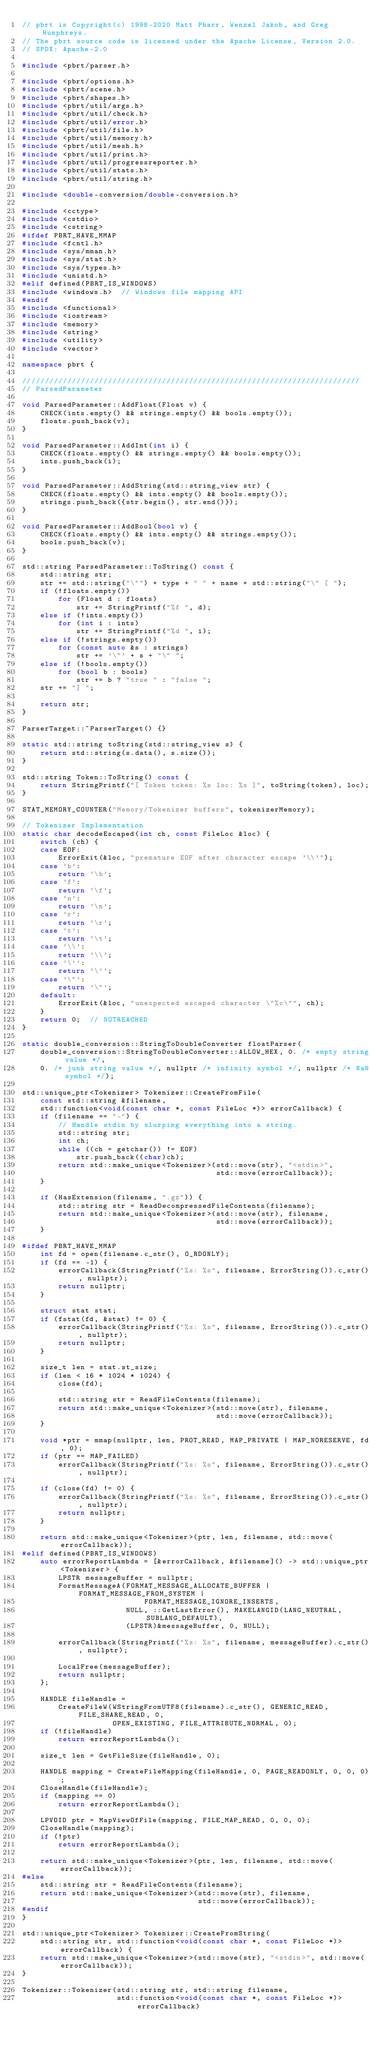Convert code to text. <code><loc_0><loc_0><loc_500><loc_500><_C++_>// pbrt is Copyright(c) 1998-2020 Matt Pharr, Wenzel Jakob, and Greg Humphreys.
// The pbrt source code is licensed under the Apache License, Version 2.0.
// SPDX: Apache-2.0

#include <pbrt/parser.h>

#include <pbrt/options.h>
#include <pbrt/scene.h>
#include <pbrt/shapes.h>
#include <pbrt/util/args.h>
#include <pbrt/util/check.h>
#include <pbrt/util/error.h>
#include <pbrt/util/file.h>
#include <pbrt/util/memory.h>
#include <pbrt/util/mesh.h>
#include <pbrt/util/print.h>
#include <pbrt/util/progressreporter.h>
#include <pbrt/util/stats.h>
#include <pbrt/util/string.h>

#include <double-conversion/double-conversion.h>

#include <cctype>
#include <cstdio>
#include <cstring>
#ifdef PBRT_HAVE_MMAP
#include <fcntl.h>
#include <sys/mman.h>
#include <sys/stat.h>
#include <sys/types.h>
#include <unistd.h>
#elif defined(PBRT_IS_WINDOWS)
#include <windows.h>  // Windows file mapping API
#endif
#include <functional>
#include <iostream>
#include <memory>
#include <string>
#include <utility>
#include <vector>

namespace pbrt {

///////////////////////////////////////////////////////////////////////////
// ParsedParameter

void ParsedParameter::AddFloat(Float v) {
    CHECK(ints.empty() && strings.empty() && bools.empty());
    floats.push_back(v);
}

void ParsedParameter::AddInt(int i) {
    CHECK(floats.empty() && strings.empty() && bools.empty());
    ints.push_back(i);
}

void ParsedParameter::AddString(std::string_view str) {
    CHECK(floats.empty() && ints.empty() && bools.empty());
    strings.push_back({str.begin(), str.end()});
}

void ParsedParameter::AddBool(bool v) {
    CHECK(floats.empty() && ints.empty() && strings.empty());
    bools.push_back(v);
}

std::string ParsedParameter::ToString() const {
    std::string str;
    str += std::string("\"") + type + " " + name + std::string("\" [ ");
    if (!floats.empty())
        for (Float d : floats)
            str += StringPrintf("%f ", d);
    else if (!ints.empty())
        for (int i : ints)
            str += StringPrintf("%d ", i);
    else if (!strings.empty())
        for (const auto &s : strings)
            str += '\"' + s + "\" ";
    else if (!bools.empty())
        for (bool b : bools)
            str += b ? "true " : "false ";
    str += "] ";

    return str;
}

ParserTarget::~ParserTarget() {}

static std::string toString(std::string_view s) {
    return std::string(s.data(), s.size());
}

std::string Token::ToString() const {
    return StringPrintf("[ Token token: %s loc: %s ]", toString(token), loc);
}

STAT_MEMORY_COUNTER("Memory/Tokenizer buffers", tokenizerMemory);

// Tokenizer Implementation
static char decodeEscaped(int ch, const FileLoc &loc) {
    switch (ch) {
    case EOF:
        ErrorExit(&loc, "premature EOF after character escape '\\'");
    case 'b':
        return '\b';
    case 'f':
        return '\f';
    case 'n':
        return '\n';
    case 'r':
        return '\r';
    case 't':
        return '\t';
    case '\\':
        return '\\';
    case '\'':
        return '\'';
    case '\"':
        return '\"';
    default:
        ErrorExit(&loc, "unexpected escaped character \"%c\"", ch);
    }
    return 0;  // NOTREACHED
}

static double_conversion::StringToDoubleConverter floatParser(
    double_conversion::StringToDoubleConverter::ALLOW_HEX, 0. /* empty string value */,
    0. /* junk string value */, nullptr /* infinity symbol */, nullptr /* NaN symbol */);

std::unique_ptr<Tokenizer> Tokenizer::CreateFromFile(
    const std::string &filename,
    std::function<void(const char *, const FileLoc *)> errorCallback) {
    if (filename == "-") {
        // Handle stdin by slurping everything into a string.
        std::string str;
        int ch;
        while ((ch = getchar()) != EOF)
            str.push_back((char)ch);
        return std::make_unique<Tokenizer>(std::move(str), "<stdin>",
                                           std::move(errorCallback));
    }

    if (HasExtension(filename, ".gz")) {
        std::string str = ReadDecompressedFileContents(filename);
        return std::make_unique<Tokenizer>(std::move(str), filename,
                                           std::move(errorCallback));
    }

#ifdef PBRT_HAVE_MMAP
    int fd = open(filename.c_str(), O_RDONLY);
    if (fd == -1) {
        errorCallback(StringPrintf("%s: %s", filename, ErrorString()).c_str(), nullptr);
        return nullptr;
    }

    struct stat stat;
    if (fstat(fd, &stat) != 0) {
        errorCallback(StringPrintf("%s: %s", filename, ErrorString()).c_str(), nullptr);
        return nullptr;
    }

    size_t len = stat.st_size;
    if (len < 16 * 1024 * 1024) {
        close(fd);

        std::string str = ReadFileContents(filename);
        return std::make_unique<Tokenizer>(std::move(str), filename,
                                           std::move(errorCallback));
    }

    void *ptr = mmap(nullptr, len, PROT_READ, MAP_PRIVATE | MAP_NORESERVE, fd, 0);
    if (ptr == MAP_FAILED)
        errorCallback(StringPrintf("%s: %s", filename, ErrorString()).c_str(), nullptr);

    if (close(fd) != 0) {
        errorCallback(StringPrintf("%s: %s", filename, ErrorString()).c_str(), nullptr);
        return nullptr;
    }

    return std::make_unique<Tokenizer>(ptr, len, filename, std::move(errorCallback));
#elif defined(PBRT_IS_WINDOWS)
    auto errorReportLambda = [&errorCallback, &filename]() -> std::unique_ptr<Tokenizer> {
        LPSTR messageBuffer = nullptr;
        FormatMessageA(FORMAT_MESSAGE_ALLOCATE_BUFFER | FORMAT_MESSAGE_FROM_SYSTEM |
                           FORMAT_MESSAGE_IGNORE_INSERTS,
                       NULL, ::GetLastError(), MAKELANGID(LANG_NEUTRAL, SUBLANG_DEFAULT),
                       (LPSTR)&messageBuffer, 0, NULL);

        errorCallback(StringPrintf("%s: %s", filename, messageBuffer).c_str(), nullptr);

        LocalFree(messageBuffer);
        return nullptr;
    };

    HANDLE fileHandle =
        CreateFileW(WStringFromUTF8(filename).c_str(), GENERIC_READ, FILE_SHARE_READ, 0,
                    OPEN_EXISTING, FILE_ATTRIBUTE_NORMAL, 0);
    if (!fileHandle)
        return errorReportLambda();

    size_t len = GetFileSize(fileHandle, 0);

    HANDLE mapping = CreateFileMapping(fileHandle, 0, PAGE_READONLY, 0, 0, 0);
    CloseHandle(fileHandle);
    if (mapping == 0)
        return errorReportLambda();

    LPVOID ptr = MapViewOfFile(mapping, FILE_MAP_READ, 0, 0, 0);
    CloseHandle(mapping);
    if (!ptr)
        return errorReportLambda();

    return std::make_unique<Tokenizer>(ptr, len, filename, std::move(errorCallback));
#else
    std::string str = ReadFileContents(filename);
    return std::make_unique<Tokenizer>(std::move(str), filename,
                                       std::move(errorCallback));
#endif
}

std::unique_ptr<Tokenizer> Tokenizer::CreateFromString(
    std::string str, std::function<void(const char *, const FileLoc *)> errorCallback) {
    return std::make_unique<Tokenizer>(std::move(str), "<stdin>", std::move(errorCallback));
}

Tokenizer::Tokenizer(std::string str, std::string filename,
                     std::function<void(const char *, const FileLoc *)> errorCallback)</code> 